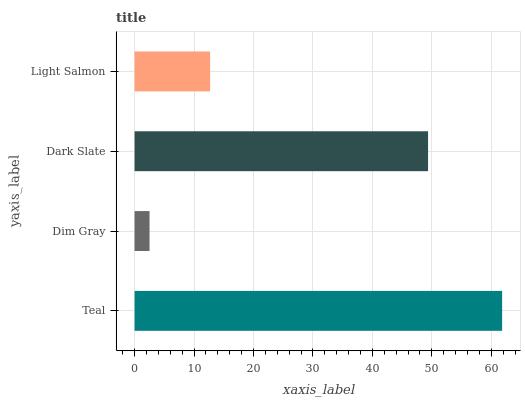Is Dim Gray the minimum?
Answer yes or no. Yes. Is Teal the maximum?
Answer yes or no. Yes. Is Dark Slate the minimum?
Answer yes or no. No. Is Dark Slate the maximum?
Answer yes or no. No. Is Dark Slate greater than Dim Gray?
Answer yes or no. Yes. Is Dim Gray less than Dark Slate?
Answer yes or no. Yes. Is Dim Gray greater than Dark Slate?
Answer yes or no. No. Is Dark Slate less than Dim Gray?
Answer yes or no. No. Is Dark Slate the high median?
Answer yes or no. Yes. Is Light Salmon the low median?
Answer yes or no. Yes. Is Dim Gray the high median?
Answer yes or no. No. Is Teal the low median?
Answer yes or no. No. 